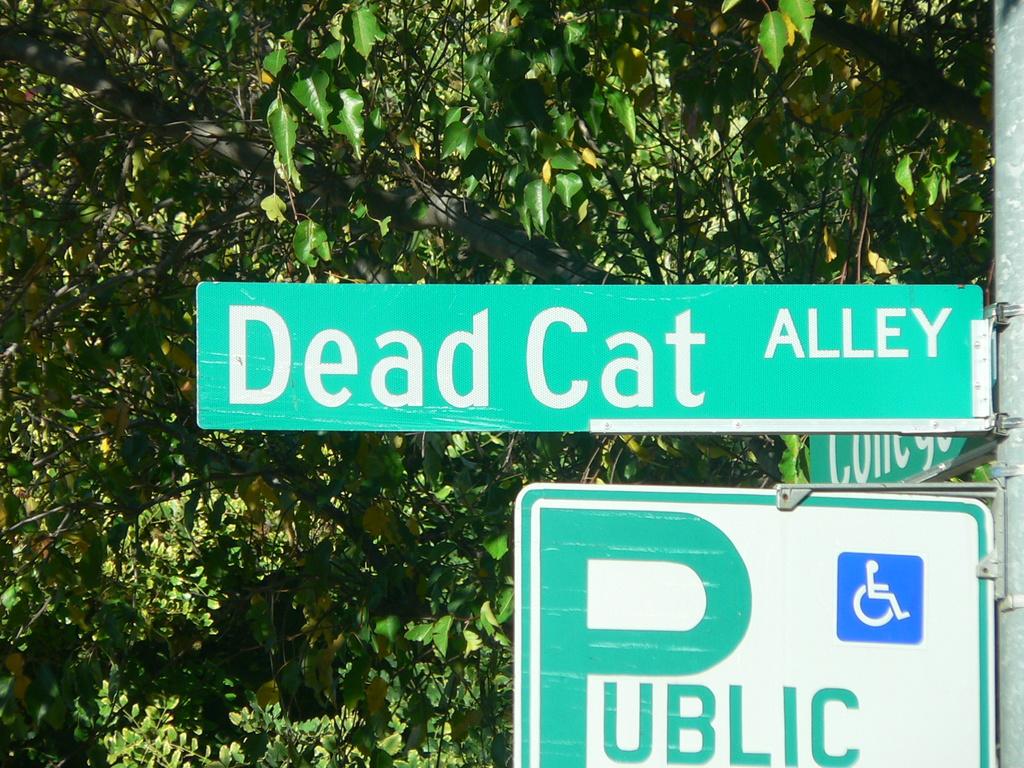What street is public?
Ensure brevity in your answer.  Dead cat alley. Is it a street or an alley?
Your answer should be very brief. Alley. 